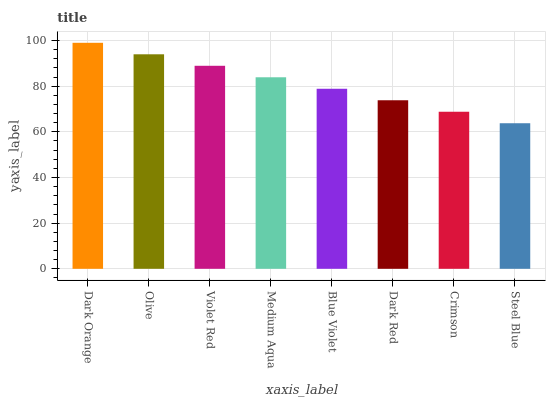Is Steel Blue the minimum?
Answer yes or no. Yes. Is Dark Orange the maximum?
Answer yes or no. Yes. Is Olive the minimum?
Answer yes or no. No. Is Olive the maximum?
Answer yes or no. No. Is Dark Orange greater than Olive?
Answer yes or no. Yes. Is Olive less than Dark Orange?
Answer yes or no. Yes. Is Olive greater than Dark Orange?
Answer yes or no. No. Is Dark Orange less than Olive?
Answer yes or no. No. Is Medium Aqua the high median?
Answer yes or no. Yes. Is Blue Violet the low median?
Answer yes or no. Yes. Is Violet Red the high median?
Answer yes or no. No. Is Olive the low median?
Answer yes or no. No. 